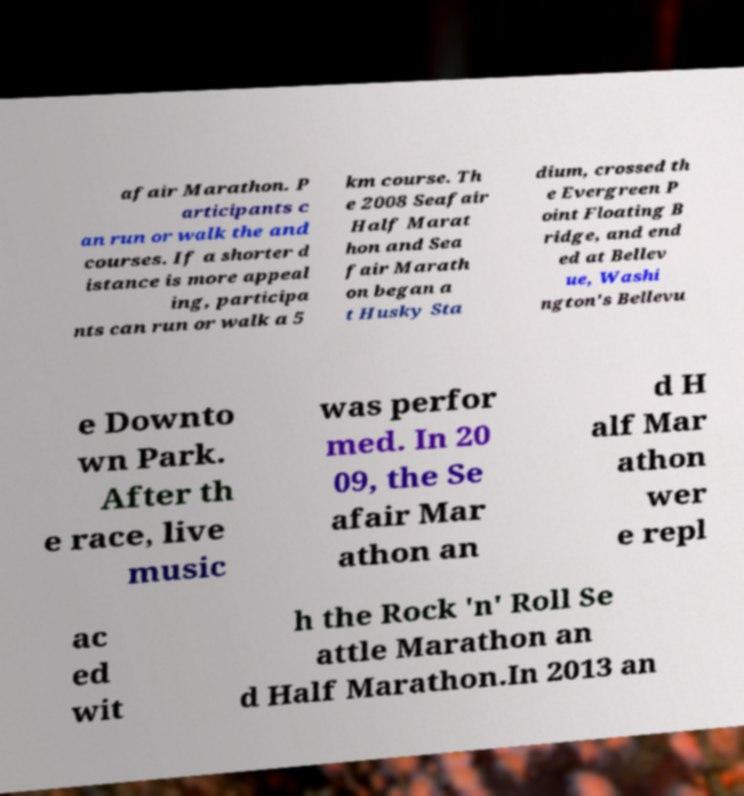Could you extract and type out the text from this image? afair Marathon. P articipants c an run or walk the and courses. If a shorter d istance is more appeal ing, participa nts can run or walk a 5 km course. Th e 2008 Seafair Half Marat hon and Sea fair Marath on began a t Husky Sta dium, crossed th e Evergreen P oint Floating B ridge, and end ed at Bellev ue, Washi ngton's Bellevu e Downto wn Park. After th e race, live music was perfor med. In 20 09, the Se afair Mar athon an d H alf Mar athon wer e repl ac ed wit h the Rock 'n' Roll Se attle Marathon an d Half Marathon.In 2013 an 